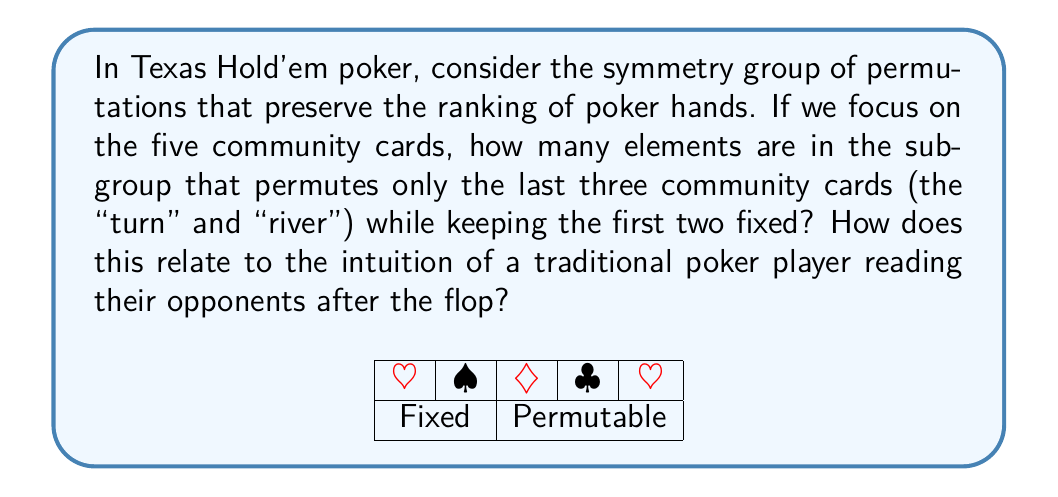Can you solve this math problem? Let's approach this step-by-step:

1) In Texas Hold'em, the five community cards consist of the flop (first three cards), the turn (fourth card), and the river (fifth card).

2) We're asked to consider permutations of only the last two cards (turn and river) while keeping the flop fixed.

3) This is equivalent to finding the number of ways to arrange 2 distinct objects, which is given by the factorial of 2:

   $$2! = 2 \times 1 = 2$$

4) Therefore, there are 2 elements in this subgroup:
   - The identity permutation (leaving the turn and river as they are)
   - The permutation that swaps the turn and river

5) Algebraically, this subgroup is isomorphic to the cyclic group of order 2, denoted as $C_2$ or $\mathbb{Z}_2$.

6) For a traditional poker player relying on intuition, this symmetry reflects the fact that after the flop, there are essentially two scenarios to consider:
   a) The turn card significantly changes the board
   b) The river card significantly changes the board

   This aligns with the common poker strategy of re-evaluating hand strength and reading opponents after each new community card is revealed.

7) The small size of this group (only 2 elements) emphasizes the importance of the flop in Texas Hold'em, as it provides the most information and is not part of this symmetry group.
Answer: 2 elements; $C_2$ or $\mathbb{Z}_2$ 